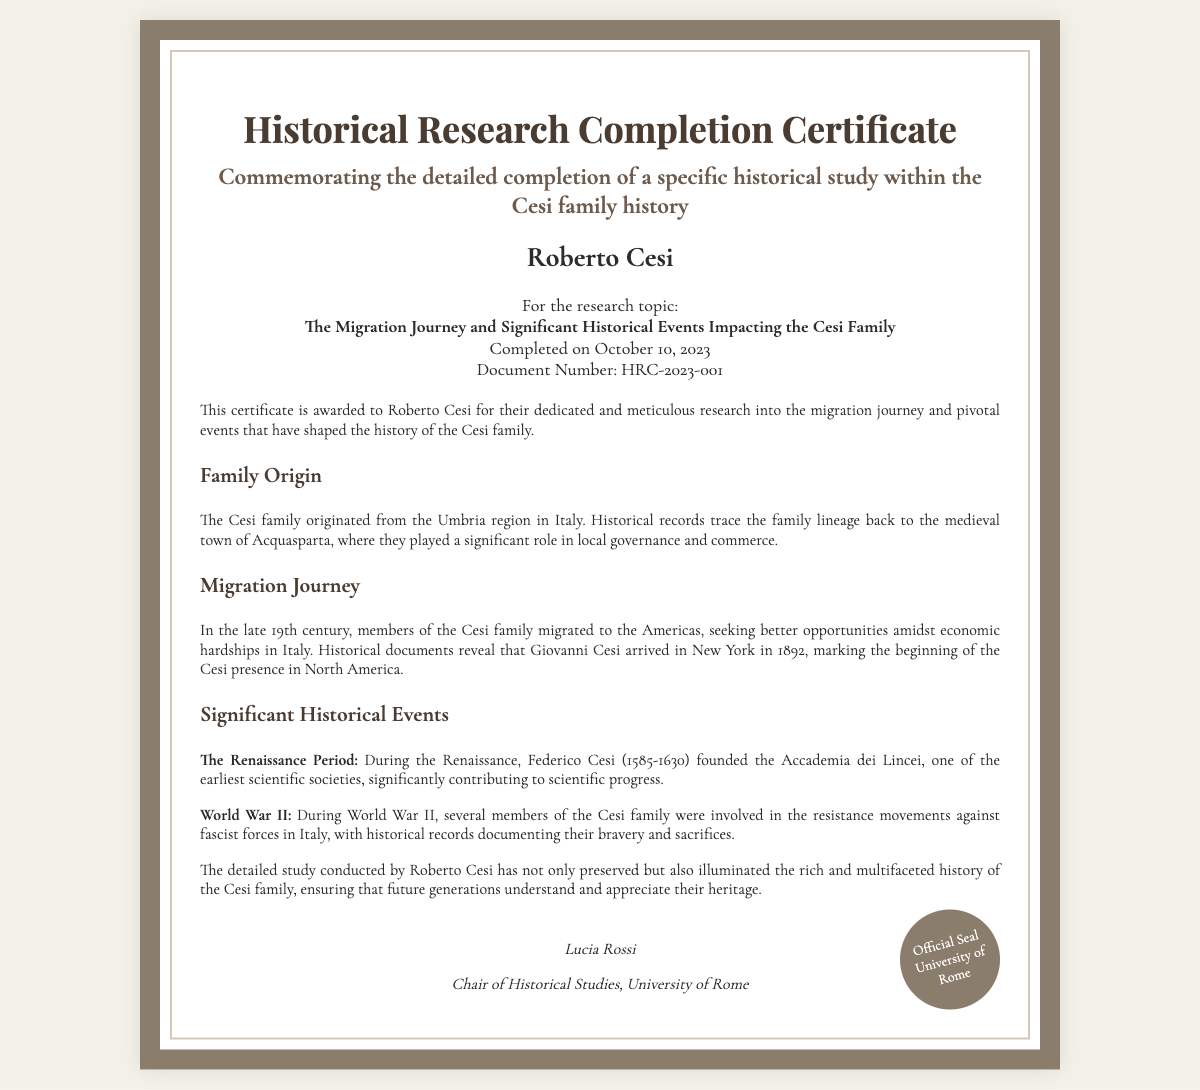What is the recipient's name? The recipient's name is stated at the top section of the certificate.
Answer: Roberto Cesi What is the research topic? The research topic is specified under the details section of the certificate.
Answer: The Migration Journey and Significant Historical Events Impacting the Cesi Family When was the research completed? The date of completion is mentioned in the details section of the certificate.
Answer: October 10, 2023 What is the document number? The document number is provided in the details section of the certificate.
Answer: HRC-2023-001 Where did the Cesi family originate? This information is provided in the content section regarding family origin.
Answer: Umbria region in Italy In what year did Giovanni Cesi arrive in New York? The year of arrival is mentioned in the migration journey section of the content.
Answer: 1892 Who founded the Accademia dei Lincei? The founder is mentioned in the significant historical events section.
Answer: Federico Cesi What significant event involved Cesi family members during World War II? The document describes involvement in resistance movements during WWII.
Answer: Resistance movements Who signed the certificate? The signatory is listed at the bottom of the certificate.
Answer: Lucia Rossi What is the title of the signatory? The title of the signatory is mentioned below their name.
Answer: Chair of Historical Studies, University of Rome 